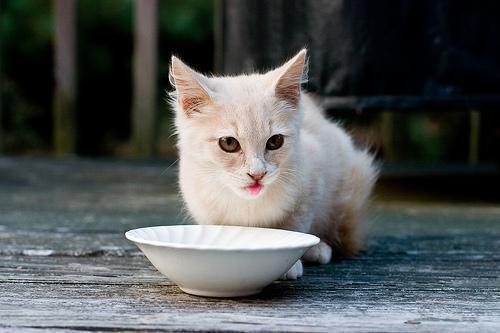How many kittens are shown?
Give a very brief answer. 1. 